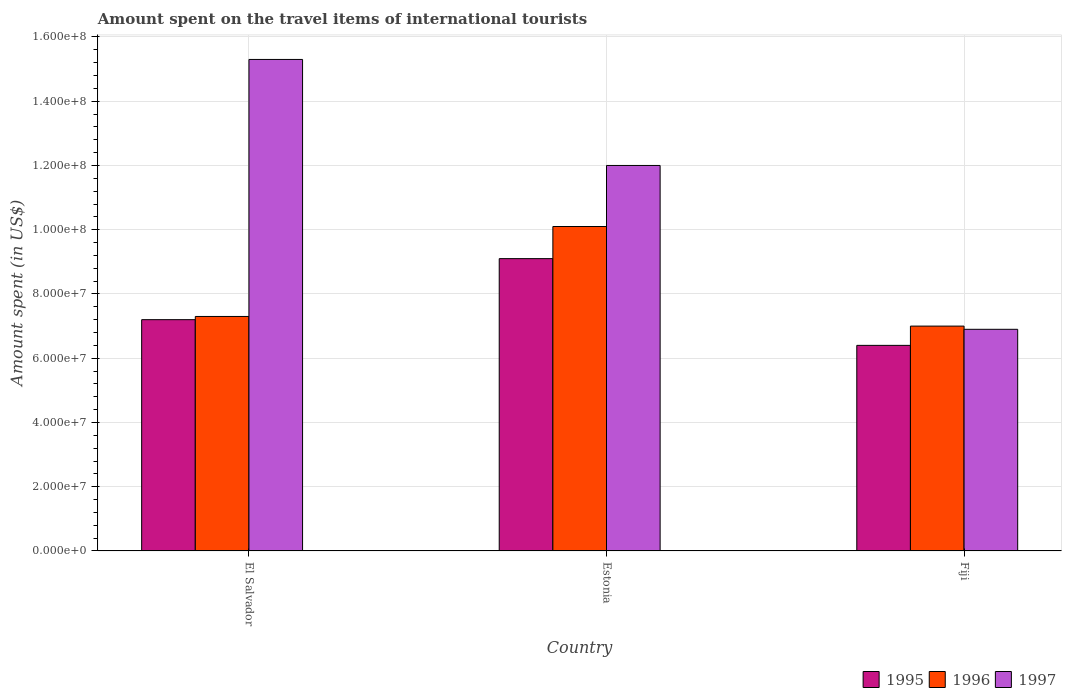How many different coloured bars are there?
Ensure brevity in your answer.  3. How many groups of bars are there?
Provide a short and direct response. 3. Are the number of bars per tick equal to the number of legend labels?
Offer a terse response. Yes. Are the number of bars on each tick of the X-axis equal?
Ensure brevity in your answer.  Yes. What is the label of the 1st group of bars from the left?
Keep it short and to the point. El Salvador. In how many cases, is the number of bars for a given country not equal to the number of legend labels?
Provide a succinct answer. 0. What is the amount spent on the travel items of international tourists in 1995 in Estonia?
Give a very brief answer. 9.10e+07. Across all countries, what is the maximum amount spent on the travel items of international tourists in 1997?
Ensure brevity in your answer.  1.53e+08. Across all countries, what is the minimum amount spent on the travel items of international tourists in 1996?
Your answer should be compact. 7.00e+07. In which country was the amount spent on the travel items of international tourists in 1996 maximum?
Ensure brevity in your answer.  Estonia. In which country was the amount spent on the travel items of international tourists in 1995 minimum?
Your answer should be very brief. Fiji. What is the total amount spent on the travel items of international tourists in 1997 in the graph?
Give a very brief answer. 3.42e+08. What is the difference between the amount spent on the travel items of international tourists in 1997 in Estonia and that in Fiji?
Give a very brief answer. 5.10e+07. What is the difference between the amount spent on the travel items of international tourists in 1997 in Fiji and the amount spent on the travel items of international tourists in 1995 in El Salvador?
Make the answer very short. -3.00e+06. What is the average amount spent on the travel items of international tourists in 1996 per country?
Your response must be concise. 8.13e+07. What is the difference between the amount spent on the travel items of international tourists of/in 1995 and amount spent on the travel items of international tourists of/in 1997 in Estonia?
Your answer should be very brief. -2.90e+07. In how many countries, is the amount spent on the travel items of international tourists in 1996 greater than 120000000 US$?
Offer a terse response. 0. What is the ratio of the amount spent on the travel items of international tourists in 1996 in Estonia to that in Fiji?
Provide a short and direct response. 1.44. Is the difference between the amount spent on the travel items of international tourists in 1995 in El Salvador and Fiji greater than the difference between the amount spent on the travel items of international tourists in 1997 in El Salvador and Fiji?
Keep it short and to the point. No. What is the difference between the highest and the second highest amount spent on the travel items of international tourists in 1996?
Offer a very short reply. 2.80e+07. What is the difference between the highest and the lowest amount spent on the travel items of international tourists in 1995?
Give a very brief answer. 2.70e+07. In how many countries, is the amount spent on the travel items of international tourists in 1996 greater than the average amount spent on the travel items of international tourists in 1996 taken over all countries?
Ensure brevity in your answer.  1. Is the sum of the amount spent on the travel items of international tourists in 1997 in El Salvador and Estonia greater than the maximum amount spent on the travel items of international tourists in 1995 across all countries?
Provide a succinct answer. Yes. What does the 3rd bar from the right in El Salvador represents?
Your response must be concise. 1995. How many bars are there?
Make the answer very short. 9. Are all the bars in the graph horizontal?
Provide a succinct answer. No. What is the difference between two consecutive major ticks on the Y-axis?
Your answer should be very brief. 2.00e+07. Are the values on the major ticks of Y-axis written in scientific E-notation?
Provide a succinct answer. Yes. Does the graph contain any zero values?
Offer a very short reply. No. Does the graph contain grids?
Offer a terse response. Yes. How many legend labels are there?
Your answer should be compact. 3. What is the title of the graph?
Your response must be concise. Amount spent on the travel items of international tourists. Does "1966" appear as one of the legend labels in the graph?
Ensure brevity in your answer.  No. What is the label or title of the Y-axis?
Your response must be concise. Amount spent (in US$). What is the Amount spent (in US$) of 1995 in El Salvador?
Provide a succinct answer. 7.20e+07. What is the Amount spent (in US$) in 1996 in El Salvador?
Provide a succinct answer. 7.30e+07. What is the Amount spent (in US$) of 1997 in El Salvador?
Give a very brief answer. 1.53e+08. What is the Amount spent (in US$) of 1995 in Estonia?
Keep it short and to the point. 9.10e+07. What is the Amount spent (in US$) in 1996 in Estonia?
Ensure brevity in your answer.  1.01e+08. What is the Amount spent (in US$) in 1997 in Estonia?
Keep it short and to the point. 1.20e+08. What is the Amount spent (in US$) in 1995 in Fiji?
Keep it short and to the point. 6.40e+07. What is the Amount spent (in US$) of 1996 in Fiji?
Keep it short and to the point. 7.00e+07. What is the Amount spent (in US$) in 1997 in Fiji?
Your answer should be compact. 6.90e+07. Across all countries, what is the maximum Amount spent (in US$) in 1995?
Your answer should be very brief. 9.10e+07. Across all countries, what is the maximum Amount spent (in US$) in 1996?
Your response must be concise. 1.01e+08. Across all countries, what is the maximum Amount spent (in US$) in 1997?
Offer a terse response. 1.53e+08. Across all countries, what is the minimum Amount spent (in US$) in 1995?
Provide a short and direct response. 6.40e+07. Across all countries, what is the minimum Amount spent (in US$) of 1996?
Make the answer very short. 7.00e+07. Across all countries, what is the minimum Amount spent (in US$) in 1997?
Your answer should be compact. 6.90e+07. What is the total Amount spent (in US$) of 1995 in the graph?
Your response must be concise. 2.27e+08. What is the total Amount spent (in US$) of 1996 in the graph?
Give a very brief answer. 2.44e+08. What is the total Amount spent (in US$) in 1997 in the graph?
Make the answer very short. 3.42e+08. What is the difference between the Amount spent (in US$) of 1995 in El Salvador and that in Estonia?
Give a very brief answer. -1.90e+07. What is the difference between the Amount spent (in US$) of 1996 in El Salvador and that in Estonia?
Ensure brevity in your answer.  -2.80e+07. What is the difference between the Amount spent (in US$) in 1997 in El Salvador and that in Estonia?
Make the answer very short. 3.30e+07. What is the difference between the Amount spent (in US$) of 1997 in El Salvador and that in Fiji?
Give a very brief answer. 8.40e+07. What is the difference between the Amount spent (in US$) in 1995 in Estonia and that in Fiji?
Provide a succinct answer. 2.70e+07. What is the difference between the Amount spent (in US$) of 1996 in Estonia and that in Fiji?
Provide a short and direct response. 3.10e+07. What is the difference between the Amount spent (in US$) of 1997 in Estonia and that in Fiji?
Your answer should be very brief. 5.10e+07. What is the difference between the Amount spent (in US$) of 1995 in El Salvador and the Amount spent (in US$) of 1996 in Estonia?
Ensure brevity in your answer.  -2.90e+07. What is the difference between the Amount spent (in US$) in 1995 in El Salvador and the Amount spent (in US$) in 1997 in Estonia?
Offer a very short reply. -4.80e+07. What is the difference between the Amount spent (in US$) of 1996 in El Salvador and the Amount spent (in US$) of 1997 in Estonia?
Your answer should be compact. -4.70e+07. What is the difference between the Amount spent (in US$) of 1995 in El Salvador and the Amount spent (in US$) of 1996 in Fiji?
Provide a succinct answer. 2.00e+06. What is the difference between the Amount spent (in US$) in 1995 in El Salvador and the Amount spent (in US$) in 1997 in Fiji?
Keep it short and to the point. 3.00e+06. What is the difference between the Amount spent (in US$) of 1995 in Estonia and the Amount spent (in US$) of 1996 in Fiji?
Offer a very short reply. 2.10e+07. What is the difference between the Amount spent (in US$) in 1995 in Estonia and the Amount spent (in US$) in 1997 in Fiji?
Provide a succinct answer. 2.20e+07. What is the difference between the Amount spent (in US$) of 1996 in Estonia and the Amount spent (in US$) of 1997 in Fiji?
Your response must be concise. 3.20e+07. What is the average Amount spent (in US$) of 1995 per country?
Provide a succinct answer. 7.57e+07. What is the average Amount spent (in US$) of 1996 per country?
Offer a terse response. 8.13e+07. What is the average Amount spent (in US$) in 1997 per country?
Provide a succinct answer. 1.14e+08. What is the difference between the Amount spent (in US$) of 1995 and Amount spent (in US$) of 1996 in El Salvador?
Your answer should be very brief. -1.00e+06. What is the difference between the Amount spent (in US$) of 1995 and Amount spent (in US$) of 1997 in El Salvador?
Keep it short and to the point. -8.10e+07. What is the difference between the Amount spent (in US$) in 1996 and Amount spent (in US$) in 1997 in El Salvador?
Ensure brevity in your answer.  -8.00e+07. What is the difference between the Amount spent (in US$) in 1995 and Amount spent (in US$) in 1996 in Estonia?
Your response must be concise. -1.00e+07. What is the difference between the Amount spent (in US$) in 1995 and Amount spent (in US$) in 1997 in Estonia?
Provide a short and direct response. -2.90e+07. What is the difference between the Amount spent (in US$) of 1996 and Amount spent (in US$) of 1997 in Estonia?
Your answer should be compact. -1.90e+07. What is the difference between the Amount spent (in US$) in 1995 and Amount spent (in US$) in 1996 in Fiji?
Keep it short and to the point. -6.00e+06. What is the difference between the Amount spent (in US$) of 1995 and Amount spent (in US$) of 1997 in Fiji?
Make the answer very short. -5.00e+06. What is the difference between the Amount spent (in US$) of 1996 and Amount spent (in US$) of 1997 in Fiji?
Your answer should be compact. 1.00e+06. What is the ratio of the Amount spent (in US$) in 1995 in El Salvador to that in Estonia?
Offer a terse response. 0.79. What is the ratio of the Amount spent (in US$) in 1996 in El Salvador to that in Estonia?
Offer a very short reply. 0.72. What is the ratio of the Amount spent (in US$) in 1997 in El Salvador to that in Estonia?
Your answer should be compact. 1.27. What is the ratio of the Amount spent (in US$) in 1996 in El Salvador to that in Fiji?
Provide a succinct answer. 1.04. What is the ratio of the Amount spent (in US$) of 1997 in El Salvador to that in Fiji?
Your answer should be compact. 2.22. What is the ratio of the Amount spent (in US$) of 1995 in Estonia to that in Fiji?
Offer a very short reply. 1.42. What is the ratio of the Amount spent (in US$) in 1996 in Estonia to that in Fiji?
Provide a short and direct response. 1.44. What is the ratio of the Amount spent (in US$) in 1997 in Estonia to that in Fiji?
Offer a very short reply. 1.74. What is the difference between the highest and the second highest Amount spent (in US$) in 1995?
Your answer should be compact. 1.90e+07. What is the difference between the highest and the second highest Amount spent (in US$) in 1996?
Your answer should be compact. 2.80e+07. What is the difference between the highest and the second highest Amount spent (in US$) in 1997?
Give a very brief answer. 3.30e+07. What is the difference between the highest and the lowest Amount spent (in US$) of 1995?
Your answer should be compact. 2.70e+07. What is the difference between the highest and the lowest Amount spent (in US$) in 1996?
Ensure brevity in your answer.  3.10e+07. What is the difference between the highest and the lowest Amount spent (in US$) in 1997?
Your answer should be compact. 8.40e+07. 